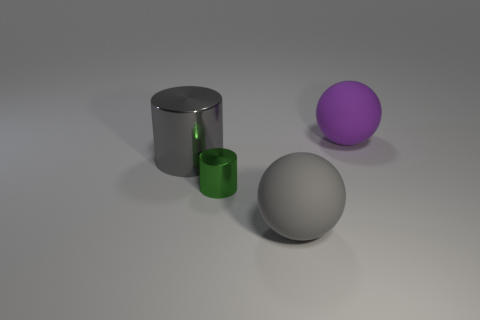Add 4 gray things. How many objects exist? 8 Add 1 matte objects. How many matte objects exist? 3 Subtract 1 gray cylinders. How many objects are left? 3 Subtract all big gray things. Subtract all tiny gray shiny objects. How many objects are left? 2 Add 2 cylinders. How many cylinders are left? 4 